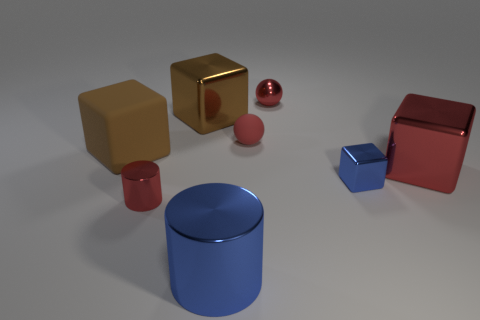Subtract all blue cubes. How many cubes are left? 3 Subtract all blue balls. How many brown blocks are left? 2 Subtract all red cubes. How many cubes are left? 3 Subtract 1 blocks. How many blocks are left? 3 Add 2 large green balls. How many objects exist? 10 Subtract all spheres. How many objects are left? 6 Subtract all cyan blocks. Subtract all red balls. How many blocks are left? 4 Subtract 0 green cubes. How many objects are left? 8 Subtract all tiny green metal objects. Subtract all small blue objects. How many objects are left? 7 Add 5 small blocks. How many small blocks are left? 6 